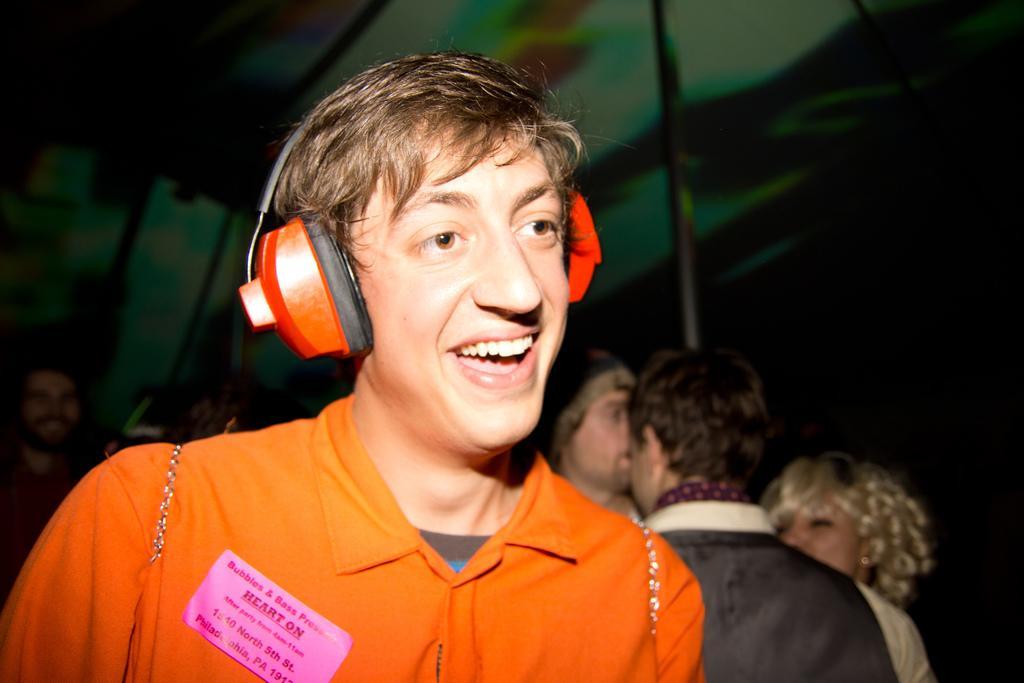Could you give a brief overview of what you see in this image? In this picture there is a man who is wearing orange shirt and headphone. In the back I can see the group of persons who are standing near to the pole. On the right I can see the darkness. At the top I can see the tent. 